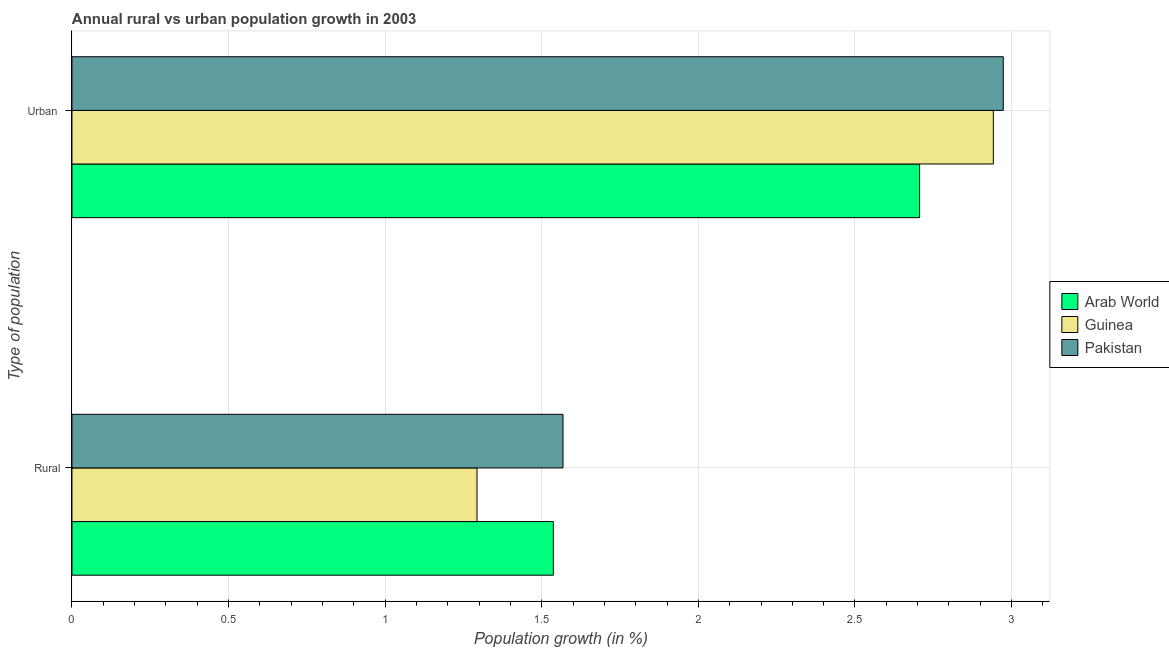Are the number of bars per tick equal to the number of legend labels?
Your response must be concise. Yes. Are the number of bars on each tick of the Y-axis equal?
Offer a terse response. Yes. What is the label of the 2nd group of bars from the top?
Ensure brevity in your answer.  Rural. What is the rural population growth in Arab World?
Provide a short and direct response. 1.54. Across all countries, what is the maximum rural population growth?
Your answer should be very brief. 1.57. Across all countries, what is the minimum urban population growth?
Provide a short and direct response. 2.71. In which country was the urban population growth minimum?
Provide a succinct answer. Arab World. What is the total urban population growth in the graph?
Ensure brevity in your answer.  8.62. What is the difference between the rural population growth in Pakistan and that in Guinea?
Offer a terse response. 0.27. What is the difference between the rural population growth in Pakistan and the urban population growth in Arab World?
Keep it short and to the point. -1.14. What is the average urban population growth per country?
Offer a terse response. 2.87. What is the difference between the rural population growth and urban population growth in Guinea?
Make the answer very short. -1.65. In how many countries, is the rural population growth greater than 1.5 %?
Keep it short and to the point. 2. What is the ratio of the rural population growth in Guinea to that in Pakistan?
Keep it short and to the point. 0.82. In how many countries, is the urban population growth greater than the average urban population growth taken over all countries?
Your answer should be very brief. 2. What does the 3rd bar from the top in Rural represents?
Your answer should be compact. Arab World. What does the 1st bar from the bottom in Urban  represents?
Make the answer very short. Arab World. Are all the bars in the graph horizontal?
Your answer should be very brief. Yes. How many countries are there in the graph?
Keep it short and to the point. 3. What is the difference between two consecutive major ticks on the X-axis?
Your answer should be compact. 0.5. Where does the legend appear in the graph?
Provide a short and direct response. Center right. How many legend labels are there?
Your response must be concise. 3. What is the title of the graph?
Offer a terse response. Annual rural vs urban population growth in 2003. What is the label or title of the X-axis?
Offer a very short reply. Population growth (in %). What is the label or title of the Y-axis?
Give a very brief answer. Type of population. What is the Population growth (in %) in Arab World in Rural?
Offer a very short reply. 1.54. What is the Population growth (in %) of Guinea in Rural?
Your answer should be very brief. 1.29. What is the Population growth (in %) of Pakistan in Rural?
Give a very brief answer. 1.57. What is the Population growth (in %) in Arab World in Urban ?
Your answer should be compact. 2.71. What is the Population growth (in %) in Guinea in Urban ?
Offer a terse response. 2.94. What is the Population growth (in %) of Pakistan in Urban ?
Provide a succinct answer. 2.97. Across all Type of population, what is the maximum Population growth (in %) of Arab World?
Make the answer very short. 2.71. Across all Type of population, what is the maximum Population growth (in %) of Guinea?
Provide a short and direct response. 2.94. Across all Type of population, what is the maximum Population growth (in %) of Pakistan?
Keep it short and to the point. 2.97. Across all Type of population, what is the minimum Population growth (in %) of Arab World?
Make the answer very short. 1.54. Across all Type of population, what is the minimum Population growth (in %) in Guinea?
Keep it short and to the point. 1.29. Across all Type of population, what is the minimum Population growth (in %) of Pakistan?
Keep it short and to the point. 1.57. What is the total Population growth (in %) in Arab World in the graph?
Make the answer very short. 4.24. What is the total Population growth (in %) in Guinea in the graph?
Give a very brief answer. 4.23. What is the total Population growth (in %) in Pakistan in the graph?
Offer a very short reply. 4.54. What is the difference between the Population growth (in %) of Arab World in Rural and that in Urban ?
Keep it short and to the point. -1.17. What is the difference between the Population growth (in %) in Guinea in Rural and that in Urban ?
Provide a short and direct response. -1.65. What is the difference between the Population growth (in %) of Pakistan in Rural and that in Urban ?
Offer a very short reply. -1.41. What is the difference between the Population growth (in %) in Arab World in Rural and the Population growth (in %) in Guinea in Urban ?
Provide a short and direct response. -1.4. What is the difference between the Population growth (in %) in Arab World in Rural and the Population growth (in %) in Pakistan in Urban ?
Keep it short and to the point. -1.44. What is the difference between the Population growth (in %) of Guinea in Rural and the Population growth (in %) of Pakistan in Urban ?
Your answer should be compact. -1.68. What is the average Population growth (in %) in Arab World per Type of population?
Give a very brief answer. 2.12. What is the average Population growth (in %) in Guinea per Type of population?
Provide a succinct answer. 2.12. What is the average Population growth (in %) in Pakistan per Type of population?
Ensure brevity in your answer.  2.27. What is the difference between the Population growth (in %) of Arab World and Population growth (in %) of Guinea in Rural?
Your answer should be very brief. 0.24. What is the difference between the Population growth (in %) in Arab World and Population growth (in %) in Pakistan in Rural?
Provide a short and direct response. -0.03. What is the difference between the Population growth (in %) in Guinea and Population growth (in %) in Pakistan in Rural?
Your answer should be very brief. -0.27. What is the difference between the Population growth (in %) of Arab World and Population growth (in %) of Guinea in Urban ?
Provide a succinct answer. -0.24. What is the difference between the Population growth (in %) of Arab World and Population growth (in %) of Pakistan in Urban ?
Your response must be concise. -0.27. What is the difference between the Population growth (in %) in Guinea and Population growth (in %) in Pakistan in Urban ?
Ensure brevity in your answer.  -0.03. What is the ratio of the Population growth (in %) of Arab World in Rural to that in Urban ?
Your answer should be very brief. 0.57. What is the ratio of the Population growth (in %) in Guinea in Rural to that in Urban ?
Make the answer very short. 0.44. What is the ratio of the Population growth (in %) in Pakistan in Rural to that in Urban ?
Provide a succinct answer. 0.53. What is the difference between the highest and the second highest Population growth (in %) in Arab World?
Offer a terse response. 1.17. What is the difference between the highest and the second highest Population growth (in %) of Guinea?
Make the answer very short. 1.65. What is the difference between the highest and the second highest Population growth (in %) in Pakistan?
Ensure brevity in your answer.  1.41. What is the difference between the highest and the lowest Population growth (in %) of Arab World?
Ensure brevity in your answer.  1.17. What is the difference between the highest and the lowest Population growth (in %) in Guinea?
Offer a terse response. 1.65. What is the difference between the highest and the lowest Population growth (in %) in Pakistan?
Make the answer very short. 1.41. 